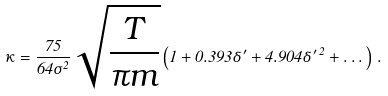<formula> <loc_0><loc_0><loc_500><loc_500>\kappa = \frac { 7 5 } { 6 4 \sigma ^ { 2 } } \sqrt { \frac { T } { \pi m } } \left ( 1 + 0 . 3 9 3 \delta ^ { \prime } + 4 . 9 0 4 \delta ^ { \prime \, 2 } + \dots \right ) \, .</formula> 